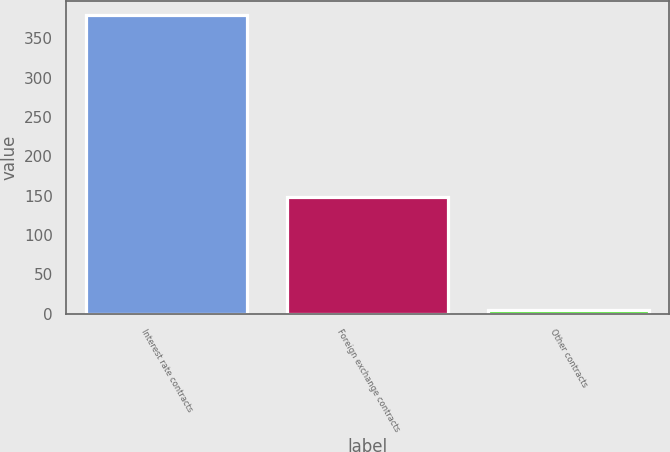Convert chart to OTSL. <chart><loc_0><loc_0><loc_500><loc_500><bar_chart><fcel>Interest rate contracts<fcel>Foreign exchange contracts<fcel>Other contracts<nl><fcel>379<fcel>149<fcel>5<nl></chart> 